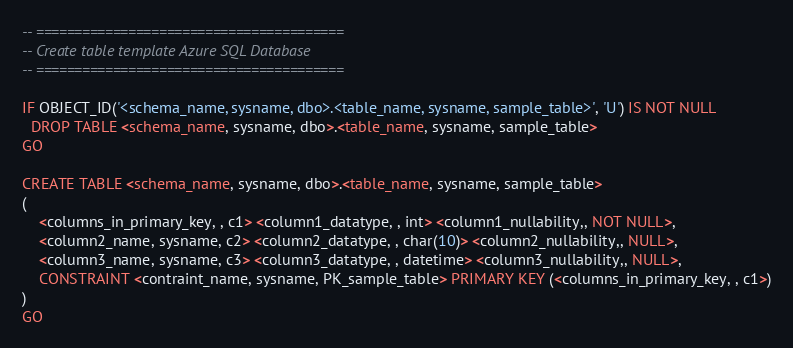Convert code to text. <code><loc_0><loc_0><loc_500><loc_500><_SQL_>-- ========================================
-- Create table template Azure SQL Database 
-- ========================================

IF OBJECT_ID('<schema_name, sysname, dbo>.<table_name, sysname, sample_table>', 'U') IS NOT NULL
  DROP TABLE <schema_name, sysname, dbo>.<table_name, sysname, sample_table>
GO

CREATE TABLE <schema_name, sysname, dbo>.<table_name, sysname, sample_table>
(
	<columns_in_primary_key, , c1> <column1_datatype, , int> <column1_nullability,, NOT NULL>, 
	<column2_name, sysname, c2> <column2_datatype, , char(10)> <column2_nullability,, NULL>, 
	<column3_name, sysname, c3> <column3_datatype, , datetime> <column3_nullability,, NULL>, 
    CONSTRAINT <contraint_name, sysname, PK_sample_table> PRIMARY KEY (<columns_in_primary_key, , c1>)
)
GO
</code> 